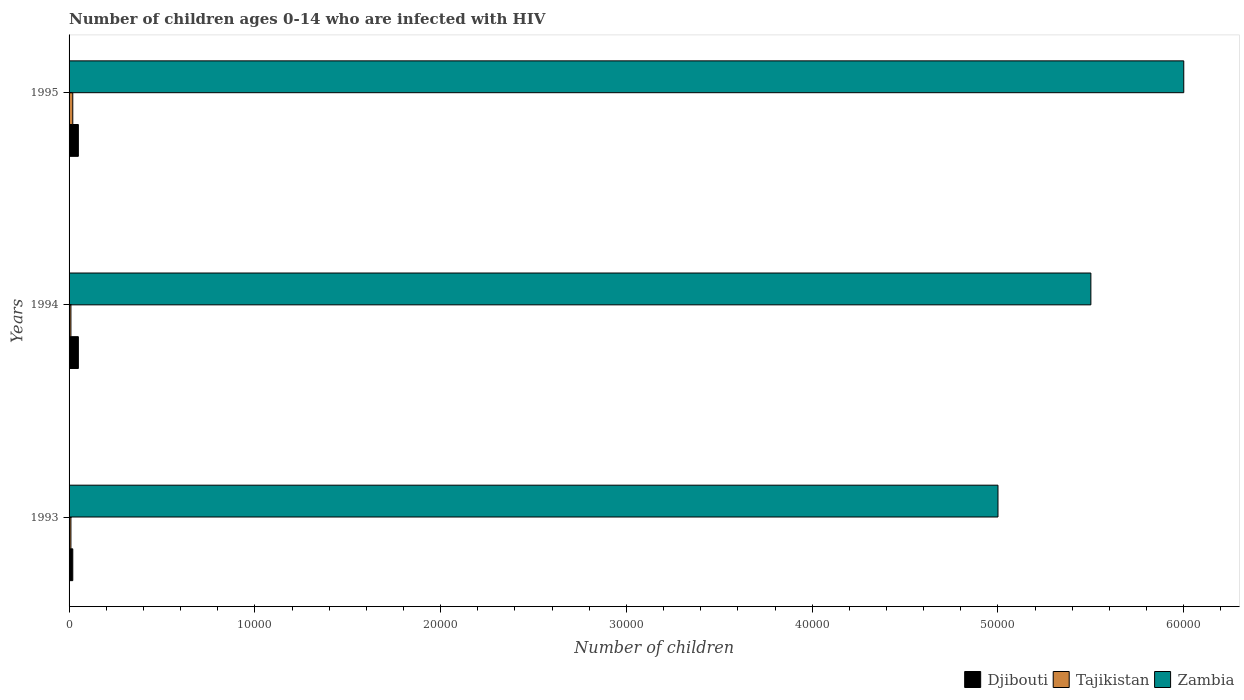How many different coloured bars are there?
Provide a short and direct response. 3. Are the number of bars on each tick of the Y-axis equal?
Your answer should be compact. Yes. In how many cases, is the number of bars for a given year not equal to the number of legend labels?
Make the answer very short. 0. What is the number of HIV infected children in Djibouti in 1994?
Offer a terse response. 500. Across all years, what is the maximum number of HIV infected children in Tajikistan?
Make the answer very short. 200. Across all years, what is the minimum number of HIV infected children in Zambia?
Your answer should be very brief. 5.00e+04. In which year was the number of HIV infected children in Djibouti maximum?
Provide a short and direct response. 1994. In which year was the number of HIV infected children in Djibouti minimum?
Make the answer very short. 1993. What is the total number of HIV infected children in Tajikistan in the graph?
Your response must be concise. 400. What is the difference between the number of HIV infected children in Zambia in 1993 and that in 1994?
Your response must be concise. -5000. What is the difference between the number of HIV infected children in Tajikistan in 1994 and the number of HIV infected children in Zambia in 1995?
Your response must be concise. -5.99e+04. What is the average number of HIV infected children in Tajikistan per year?
Offer a terse response. 133.33. In the year 1994, what is the difference between the number of HIV infected children in Tajikistan and number of HIV infected children in Djibouti?
Your response must be concise. -400. In how many years, is the number of HIV infected children in Djibouti greater than 32000 ?
Provide a short and direct response. 0. Is the number of HIV infected children in Tajikistan in 1994 less than that in 1995?
Make the answer very short. Yes. What is the difference between the highest and the second highest number of HIV infected children in Tajikistan?
Provide a succinct answer. 100. What is the difference between the highest and the lowest number of HIV infected children in Djibouti?
Your response must be concise. 300. Is the sum of the number of HIV infected children in Zambia in 1993 and 1995 greater than the maximum number of HIV infected children in Tajikistan across all years?
Provide a short and direct response. Yes. What does the 1st bar from the top in 1995 represents?
Give a very brief answer. Zambia. What does the 3rd bar from the bottom in 1993 represents?
Offer a very short reply. Zambia. Is it the case that in every year, the sum of the number of HIV infected children in Zambia and number of HIV infected children in Tajikistan is greater than the number of HIV infected children in Djibouti?
Your response must be concise. Yes. Are all the bars in the graph horizontal?
Offer a very short reply. Yes. How many years are there in the graph?
Offer a terse response. 3. Where does the legend appear in the graph?
Your answer should be very brief. Bottom right. How many legend labels are there?
Your answer should be very brief. 3. What is the title of the graph?
Your answer should be very brief. Number of children ages 0-14 who are infected with HIV. Does "Comoros" appear as one of the legend labels in the graph?
Offer a very short reply. No. What is the label or title of the X-axis?
Your answer should be compact. Number of children. What is the label or title of the Y-axis?
Offer a terse response. Years. What is the Number of children of Djibouti in 1993?
Give a very brief answer. 200. What is the Number of children of Tajikistan in 1993?
Your response must be concise. 100. What is the Number of children in Zambia in 1994?
Offer a terse response. 5.50e+04. What is the Number of children in Tajikistan in 1995?
Your answer should be compact. 200. Across all years, what is the maximum Number of children of Zambia?
Provide a succinct answer. 6.00e+04. Across all years, what is the minimum Number of children of Tajikistan?
Give a very brief answer. 100. Across all years, what is the minimum Number of children of Zambia?
Your response must be concise. 5.00e+04. What is the total Number of children in Djibouti in the graph?
Your answer should be compact. 1200. What is the total Number of children in Tajikistan in the graph?
Offer a very short reply. 400. What is the total Number of children of Zambia in the graph?
Provide a succinct answer. 1.65e+05. What is the difference between the Number of children of Djibouti in 1993 and that in 1994?
Keep it short and to the point. -300. What is the difference between the Number of children in Zambia in 1993 and that in 1994?
Give a very brief answer. -5000. What is the difference between the Number of children of Djibouti in 1993 and that in 1995?
Provide a succinct answer. -300. What is the difference between the Number of children of Tajikistan in 1993 and that in 1995?
Provide a succinct answer. -100. What is the difference between the Number of children of Zambia in 1993 and that in 1995?
Give a very brief answer. -10000. What is the difference between the Number of children of Djibouti in 1994 and that in 1995?
Provide a short and direct response. 0. What is the difference between the Number of children in Tajikistan in 1994 and that in 1995?
Make the answer very short. -100. What is the difference between the Number of children of Zambia in 1994 and that in 1995?
Your response must be concise. -5000. What is the difference between the Number of children in Djibouti in 1993 and the Number of children in Zambia in 1994?
Make the answer very short. -5.48e+04. What is the difference between the Number of children in Tajikistan in 1993 and the Number of children in Zambia in 1994?
Keep it short and to the point. -5.49e+04. What is the difference between the Number of children in Djibouti in 1993 and the Number of children in Zambia in 1995?
Keep it short and to the point. -5.98e+04. What is the difference between the Number of children of Tajikistan in 1993 and the Number of children of Zambia in 1995?
Your answer should be very brief. -5.99e+04. What is the difference between the Number of children of Djibouti in 1994 and the Number of children of Tajikistan in 1995?
Your answer should be compact. 300. What is the difference between the Number of children of Djibouti in 1994 and the Number of children of Zambia in 1995?
Make the answer very short. -5.95e+04. What is the difference between the Number of children of Tajikistan in 1994 and the Number of children of Zambia in 1995?
Make the answer very short. -5.99e+04. What is the average Number of children in Djibouti per year?
Give a very brief answer. 400. What is the average Number of children in Tajikistan per year?
Provide a succinct answer. 133.33. What is the average Number of children in Zambia per year?
Provide a short and direct response. 5.50e+04. In the year 1993, what is the difference between the Number of children of Djibouti and Number of children of Zambia?
Make the answer very short. -4.98e+04. In the year 1993, what is the difference between the Number of children in Tajikistan and Number of children in Zambia?
Keep it short and to the point. -4.99e+04. In the year 1994, what is the difference between the Number of children in Djibouti and Number of children in Tajikistan?
Provide a succinct answer. 400. In the year 1994, what is the difference between the Number of children of Djibouti and Number of children of Zambia?
Ensure brevity in your answer.  -5.45e+04. In the year 1994, what is the difference between the Number of children in Tajikistan and Number of children in Zambia?
Ensure brevity in your answer.  -5.49e+04. In the year 1995, what is the difference between the Number of children in Djibouti and Number of children in Tajikistan?
Keep it short and to the point. 300. In the year 1995, what is the difference between the Number of children of Djibouti and Number of children of Zambia?
Offer a very short reply. -5.95e+04. In the year 1995, what is the difference between the Number of children of Tajikistan and Number of children of Zambia?
Ensure brevity in your answer.  -5.98e+04. What is the ratio of the Number of children in Zambia in 1993 to that in 1995?
Make the answer very short. 0.83. What is the ratio of the Number of children in Tajikistan in 1994 to that in 1995?
Ensure brevity in your answer.  0.5. What is the ratio of the Number of children in Zambia in 1994 to that in 1995?
Provide a short and direct response. 0.92. What is the difference between the highest and the second highest Number of children of Djibouti?
Make the answer very short. 0. What is the difference between the highest and the lowest Number of children of Djibouti?
Offer a terse response. 300. What is the difference between the highest and the lowest Number of children of Tajikistan?
Make the answer very short. 100. 